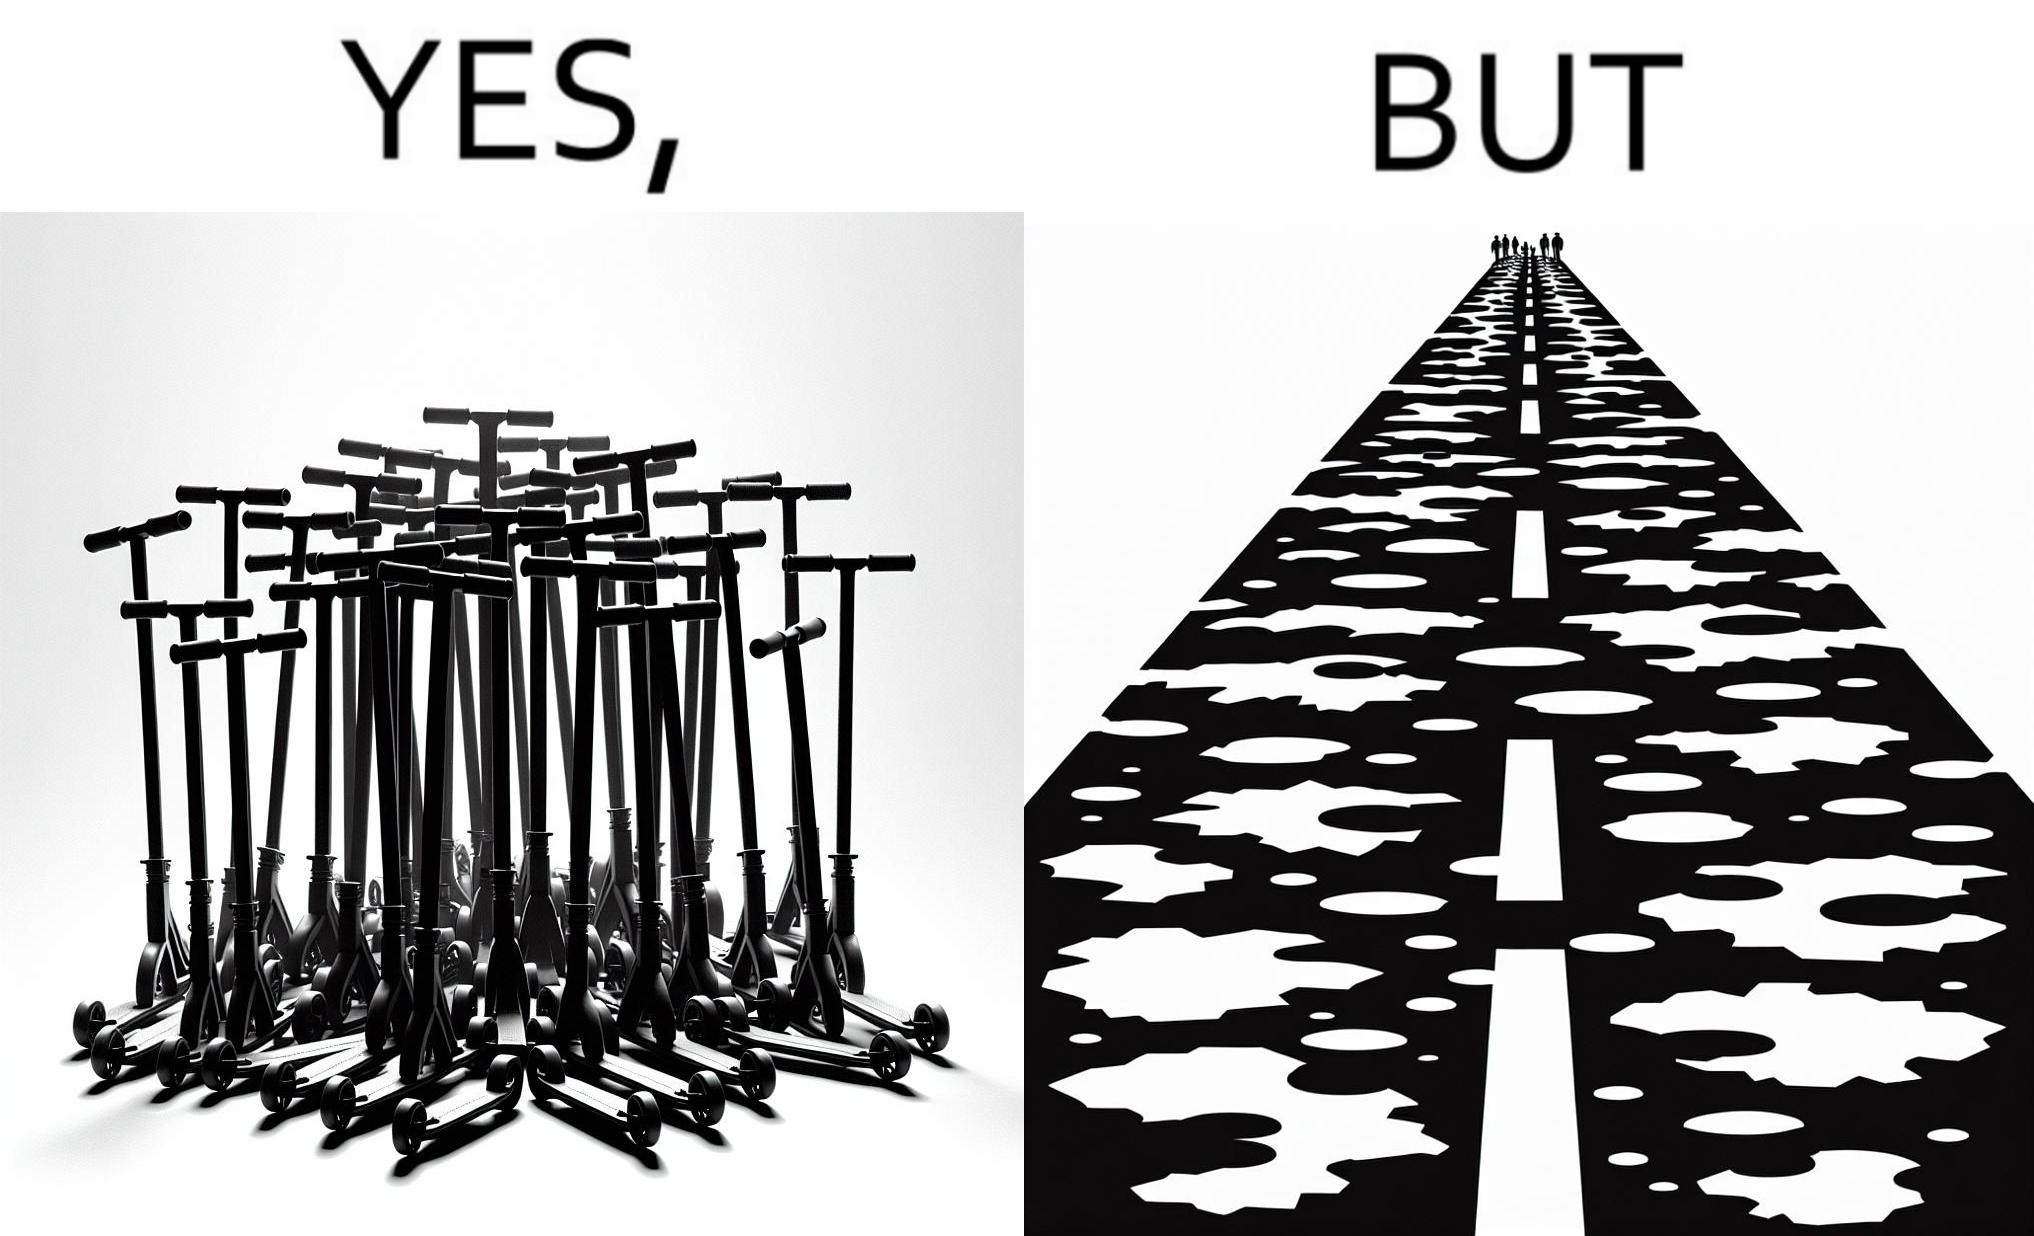Describe the satirical element in this image. The image is ironic, because even after when the skateboard scooters are available for someone to ride but the road has many potholes that it is not suitable to ride the scooters on such roads 